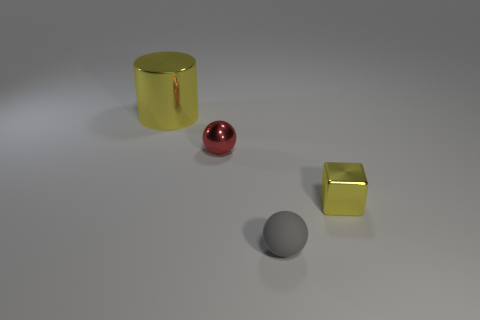Is there anything else that has the same shape as the big yellow shiny object?
Make the answer very short. No. Are there any other things that have the same size as the cylinder?
Provide a succinct answer. No. Is the number of yellow blocks less than the number of yellow shiny objects?
Your response must be concise. Yes. What number of shiny objects are purple cylinders or cubes?
Your answer should be compact. 1. Is there a small red ball that is right of the yellow metal object that is to the right of the big yellow metallic cylinder?
Your answer should be compact. No. Do the cylinder behind the red metallic thing and the small red sphere have the same material?
Offer a terse response. Yes. How many other things are the same color as the large metal thing?
Provide a short and direct response. 1. Do the metal cylinder and the block have the same color?
Offer a very short reply. Yes. What size is the yellow metal thing behind the yellow thing that is right of the small matte thing?
Provide a succinct answer. Large. Do the small ball that is behind the block and the tiny object that is on the right side of the matte ball have the same material?
Your answer should be very brief. Yes. 